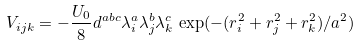<formula> <loc_0><loc_0><loc_500><loc_500>V _ { i j k } = - \frac { U _ { 0 } } { 8 } d ^ { a b c } \lambda _ { i } ^ { a } \lambda _ { j } ^ { b } \lambda _ { k } ^ { c } \, \exp ( - ( r _ { i } ^ { 2 } + r _ { j } ^ { 2 } + r _ { k } ^ { 2 } ) / a ^ { 2 } )</formula> 